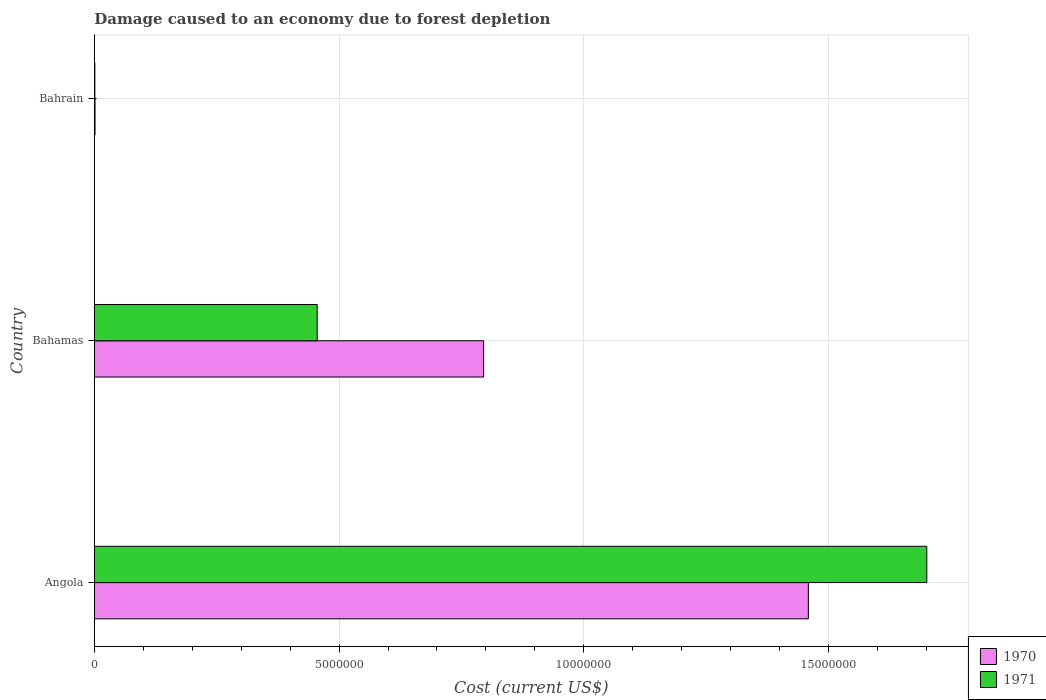How many groups of bars are there?
Give a very brief answer. 3. Are the number of bars per tick equal to the number of legend labels?
Give a very brief answer. Yes. How many bars are there on the 2nd tick from the bottom?
Keep it short and to the point. 2. What is the label of the 2nd group of bars from the top?
Your response must be concise. Bahamas. In how many cases, is the number of bars for a given country not equal to the number of legend labels?
Make the answer very short. 0. What is the cost of damage caused due to forest depletion in 1970 in Bahrain?
Your answer should be compact. 1.53e+04. Across all countries, what is the maximum cost of damage caused due to forest depletion in 1971?
Offer a terse response. 1.70e+07. Across all countries, what is the minimum cost of damage caused due to forest depletion in 1971?
Your answer should be compact. 1.16e+04. In which country was the cost of damage caused due to forest depletion in 1971 maximum?
Give a very brief answer. Angola. In which country was the cost of damage caused due to forest depletion in 1970 minimum?
Give a very brief answer. Bahrain. What is the total cost of damage caused due to forest depletion in 1970 in the graph?
Offer a very short reply. 2.26e+07. What is the difference between the cost of damage caused due to forest depletion in 1971 in Angola and that in Bahamas?
Give a very brief answer. 1.25e+07. What is the difference between the cost of damage caused due to forest depletion in 1970 in Angola and the cost of damage caused due to forest depletion in 1971 in Bahrain?
Your answer should be compact. 1.46e+07. What is the average cost of damage caused due to forest depletion in 1970 per country?
Offer a terse response. 7.52e+06. What is the difference between the cost of damage caused due to forest depletion in 1971 and cost of damage caused due to forest depletion in 1970 in Bahrain?
Give a very brief answer. -3638.2. What is the ratio of the cost of damage caused due to forest depletion in 1971 in Angola to that in Bahrain?
Make the answer very short. 1462.67. Is the cost of damage caused due to forest depletion in 1971 in Angola less than that in Bahamas?
Your response must be concise. No. What is the difference between the highest and the second highest cost of damage caused due to forest depletion in 1970?
Keep it short and to the point. 6.63e+06. What is the difference between the highest and the lowest cost of damage caused due to forest depletion in 1970?
Your answer should be very brief. 1.46e+07. How many bars are there?
Ensure brevity in your answer.  6. Are all the bars in the graph horizontal?
Provide a succinct answer. Yes. Does the graph contain any zero values?
Provide a succinct answer. No. Does the graph contain grids?
Make the answer very short. Yes. How many legend labels are there?
Give a very brief answer. 2. What is the title of the graph?
Provide a succinct answer. Damage caused to an economy due to forest depletion. Does "1970" appear as one of the legend labels in the graph?
Provide a succinct answer. Yes. What is the label or title of the X-axis?
Ensure brevity in your answer.  Cost (current US$). What is the label or title of the Y-axis?
Offer a very short reply. Country. What is the Cost (current US$) in 1970 in Angola?
Offer a terse response. 1.46e+07. What is the Cost (current US$) in 1971 in Angola?
Make the answer very short. 1.70e+07. What is the Cost (current US$) in 1970 in Bahamas?
Offer a very short reply. 7.95e+06. What is the Cost (current US$) in 1971 in Bahamas?
Your answer should be very brief. 4.55e+06. What is the Cost (current US$) in 1970 in Bahrain?
Your response must be concise. 1.53e+04. What is the Cost (current US$) of 1971 in Bahrain?
Offer a terse response. 1.16e+04. Across all countries, what is the maximum Cost (current US$) of 1970?
Offer a terse response. 1.46e+07. Across all countries, what is the maximum Cost (current US$) in 1971?
Ensure brevity in your answer.  1.70e+07. Across all countries, what is the minimum Cost (current US$) of 1970?
Offer a very short reply. 1.53e+04. Across all countries, what is the minimum Cost (current US$) in 1971?
Make the answer very short. 1.16e+04. What is the total Cost (current US$) in 1970 in the graph?
Provide a short and direct response. 2.26e+07. What is the total Cost (current US$) in 1971 in the graph?
Give a very brief answer. 2.16e+07. What is the difference between the Cost (current US$) of 1970 in Angola and that in Bahamas?
Your response must be concise. 6.63e+06. What is the difference between the Cost (current US$) in 1971 in Angola and that in Bahamas?
Ensure brevity in your answer.  1.25e+07. What is the difference between the Cost (current US$) in 1970 in Angola and that in Bahrain?
Your answer should be very brief. 1.46e+07. What is the difference between the Cost (current US$) in 1971 in Angola and that in Bahrain?
Keep it short and to the point. 1.70e+07. What is the difference between the Cost (current US$) in 1970 in Bahamas and that in Bahrain?
Give a very brief answer. 7.94e+06. What is the difference between the Cost (current US$) in 1971 in Bahamas and that in Bahrain?
Offer a terse response. 4.54e+06. What is the difference between the Cost (current US$) of 1970 in Angola and the Cost (current US$) of 1971 in Bahamas?
Your response must be concise. 1.00e+07. What is the difference between the Cost (current US$) in 1970 in Angola and the Cost (current US$) in 1971 in Bahrain?
Ensure brevity in your answer.  1.46e+07. What is the difference between the Cost (current US$) in 1970 in Bahamas and the Cost (current US$) in 1971 in Bahrain?
Your response must be concise. 7.94e+06. What is the average Cost (current US$) in 1970 per country?
Your answer should be compact. 7.52e+06. What is the average Cost (current US$) in 1971 per country?
Your answer should be compact. 7.19e+06. What is the difference between the Cost (current US$) of 1970 and Cost (current US$) of 1971 in Angola?
Your answer should be very brief. -2.42e+06. What is the difference between the Cost (current US$) of 1970 and Cost (current US$) of 1971 in Bahamas?
Offer a very short reply. 3.40e+06. What is the difference between the Cost (current US$) of 1970 and Cost (current US$) of 1971 in Bahrain?
Your answer should be very brief. 3638.2. What is the ratio of the Cost (current US$) in 1970 in Angola to that in Bahamas?
Offer a very short reply. 1.83. What is the ratio of the Cost (current US$) of 1971 in Angola to that in Bahamas?
Make the answer very short. 3.73. What is the ratio of the Cost (current US$) of 1970 in Angola to that in Bahrain?
Your response must be concise. 955.55. What is the ratio of the Cost (current US$) of 1971 in Angola to that in Bahrain?
Make the answer very short. 1462.67. What is the ratio of the Cost (current US$) of 1970 in Bahamas to that in Bahrain?
Provide a succinct answer. 520.98. What is the ratio of the Cost (current US$) of 1971 in Bahamas to that in Bahrain?
Provide a short and direct response. 391.63. What is the difference between the highest and the second highest Cost (current US$) of 1970?
Provide a succinct answer. 6.63e+06. What is the difference between the highest and the second highest Cost (current US$) of 1971?
Provide a succinct answer. 1.25e+07. What is the difference between the highest and the lowest Cost (current US$) of 1970?
Keep it short and to the point. 1.46e+07. What is the difference between the highest and the lowest Cost (current US$) in 1971?
Keep it short and to the point. 1.70e+07. 